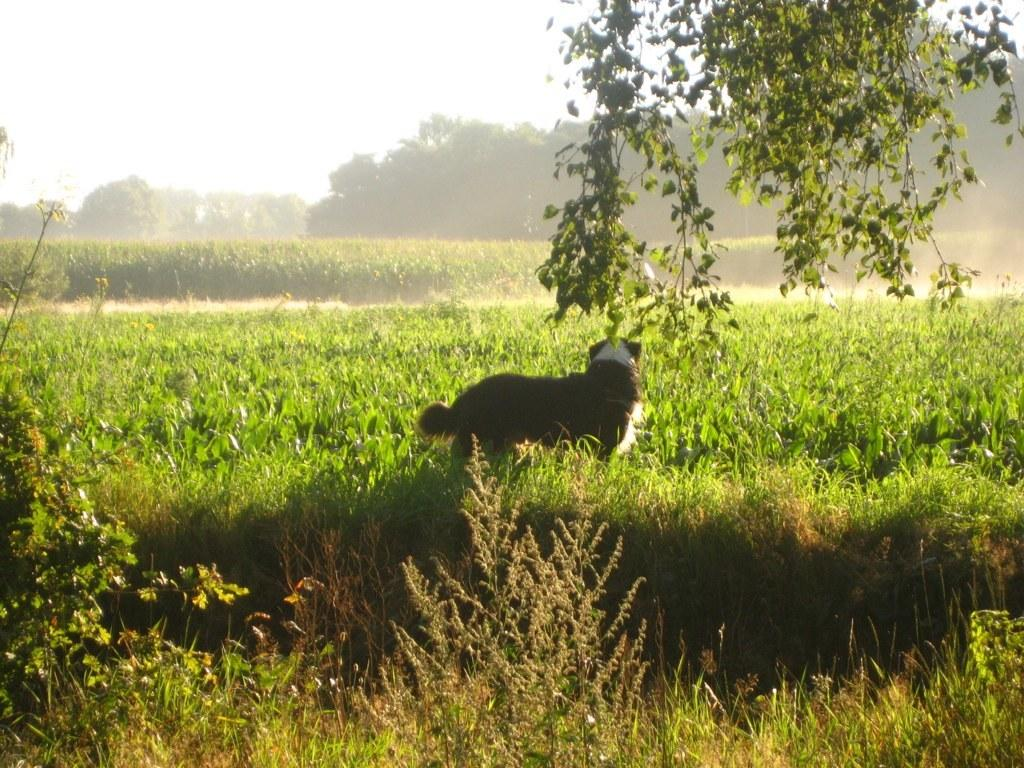What type of animal can be seen in the image? There is an animal standing on the ground in the image. What other natural elements are present in the image? There are plants, trees, and the sky visible in the image. What type of landscape is depicted in the image? Agricultural farms are visible in the image. Where is the jewel located in the image? There is no jewel present in the image. What type of food is being served in the lunchroom in the image? There is no lunchroom present in the image. 